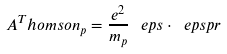Convert formula to latex. <formula><loc_0><loc_0><loc_500><loc_500>A ^ { T } h o m s o n _ { p } = \frac { e ^ { 2 } } { m _ { p } } \, \ e p s \cdot \ e p s p r</formula> 